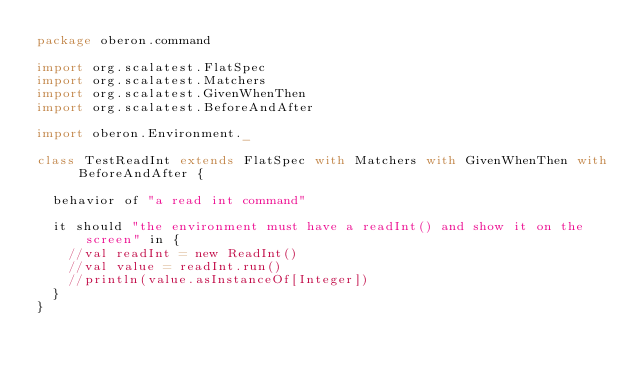Convert code to text. <code><loc_0><loc_0><loc_500><loc_500><_Scala_>package oberon.command

import org.scalatest.FlatSpec
import org.scalatest.Matchers
import org.scalatest.GivenWhenThen
import org.scalatest.BeforeAndAfter

import oberon.Environment._

class TestReadInt extends FlatSpec with Matchers with GivenWhenThen with BeforeAndAfter {

  behavior of "a read int command"

  it should "the environment must have a readInt() and show it on the screen" in {
    //val readInt = new ReadInt()
    //val value = readInt.run()
    //println(value.asInstanceOf[Integer])
  }
}
</code> 